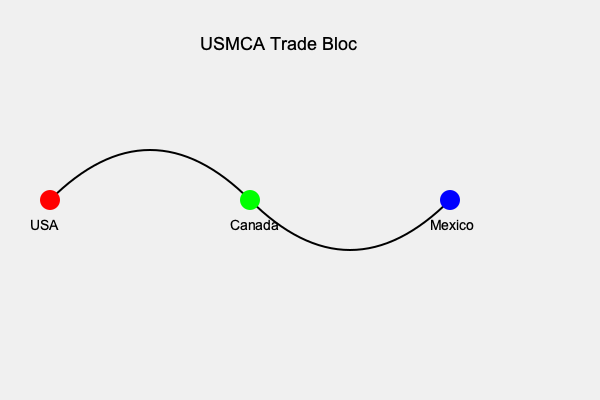Which countries are represented in this simplified map of the USMCA (United States-Mexico-Canada Agreement) trade bloc, and how might this agreement impact global trade dynamics? To answer this question, let's break it down step-by-step:

1. Identify the countries:
   - The red dot represents the United States of America (USA)
   - The green dot represents Canada
   - The blue dot represents Mexico

2. Understand the USMCA:
   - USMCA stands for United States-Mexico-Canada Agreement
   - It's a free trade agreement that replaced NAFTA (North American Free Trade Agreement) in 2020

3. Impact on global trade dynamics:
   a) Increased regional integration:
      - Strengthens North American economic ties
      - Potentially shifts some trade away from other global partners

   b) Modernized trade rules:
      - Updates regulations for digital trade and intellectual property
      - May set new standards for future global trade agreements

   c) Automotive sector changes:
      - New rules of origin requirements (e.g., 75% of auto content must be made in North America)
      - Could affect global automotive supply chains

   d) Labor and environmental standards:
      - Higher standards may influence other countries' practices
      - Could impact competitiveness with countries with lower standards

   e) Potential blueprint for other agreements:
      - May serve as a model for future U.S. trade negotiations
      - Could influence other regional trade blocs

Understanding these impacts is crucial for a politically active parent, as trade agreements significantly affect job markets, consumer goods prices, and overall economic health, which are all important factors in family well-being and political decision-making.
Answer: USA, Canada, Mexico; USMCA strengthens North American economic integration, modernizes trade rules, and may influence global trade practices and agreements. 